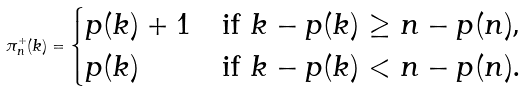<formula> <loc_0><loc_0><loc_500><loc_500>\pi ^ { + } _ { n } ( k ) = \begin{cases} p ( k ) + 1 & \text {if $k - p(k) \geq n-p(n)$,} \\ p ( k ) & \text {if $k-p(k) < n-p(n)$.} \end{cases}</formula> 